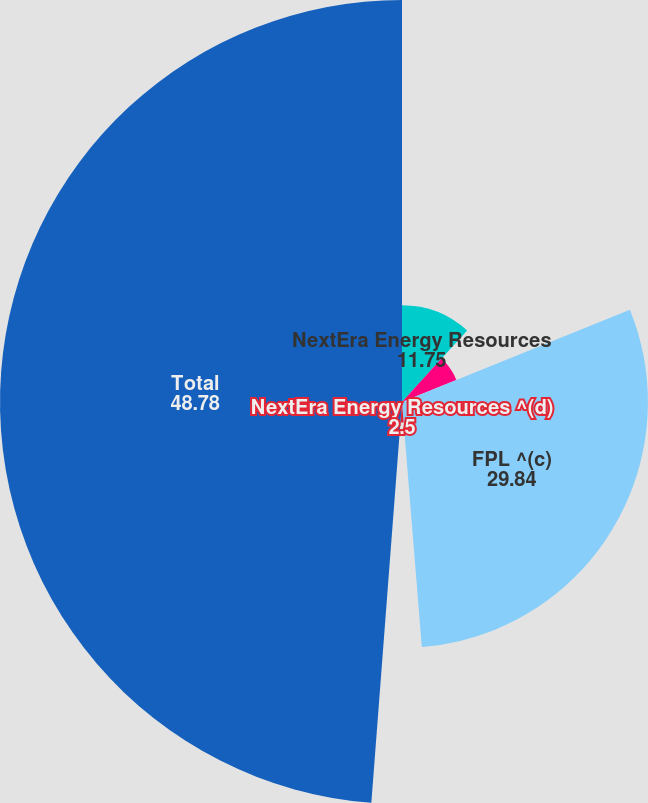<chart> <loc_0><loc_0><loc_500><loc_500><pie_chart><fcel>NextEra Energy Resources<fcel>Corporate and Other<fcel>FPL ^(c)<fcel>NextEra Energy Resources ^(d)<fcel>Total<nl><fcel>11.75%<fcel>7.12%<fcel>29.84%<fcel>2.5%<fcel>48.78%<nl></chart> 